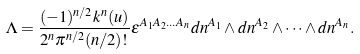Convert formula to latex. <formula><loc_0><loc_0><loc_500><loc_500>\Lambda = \frac { ( - 1 ) ^ { n / 2 } k ^ { n } ( u ) } { 2 ^ { n } \pi ^ { n / 2 } ( n / 2 ) ! } \epsilon ^ { A _ { 1 } A _ { 2 } \dots A _ { n } } d n ^ { A _ { 1 } } \wedge d n ^ { A _ { 2 } } \wedge \dots \wedge d n ^ { A _ { n } } .</formula> 